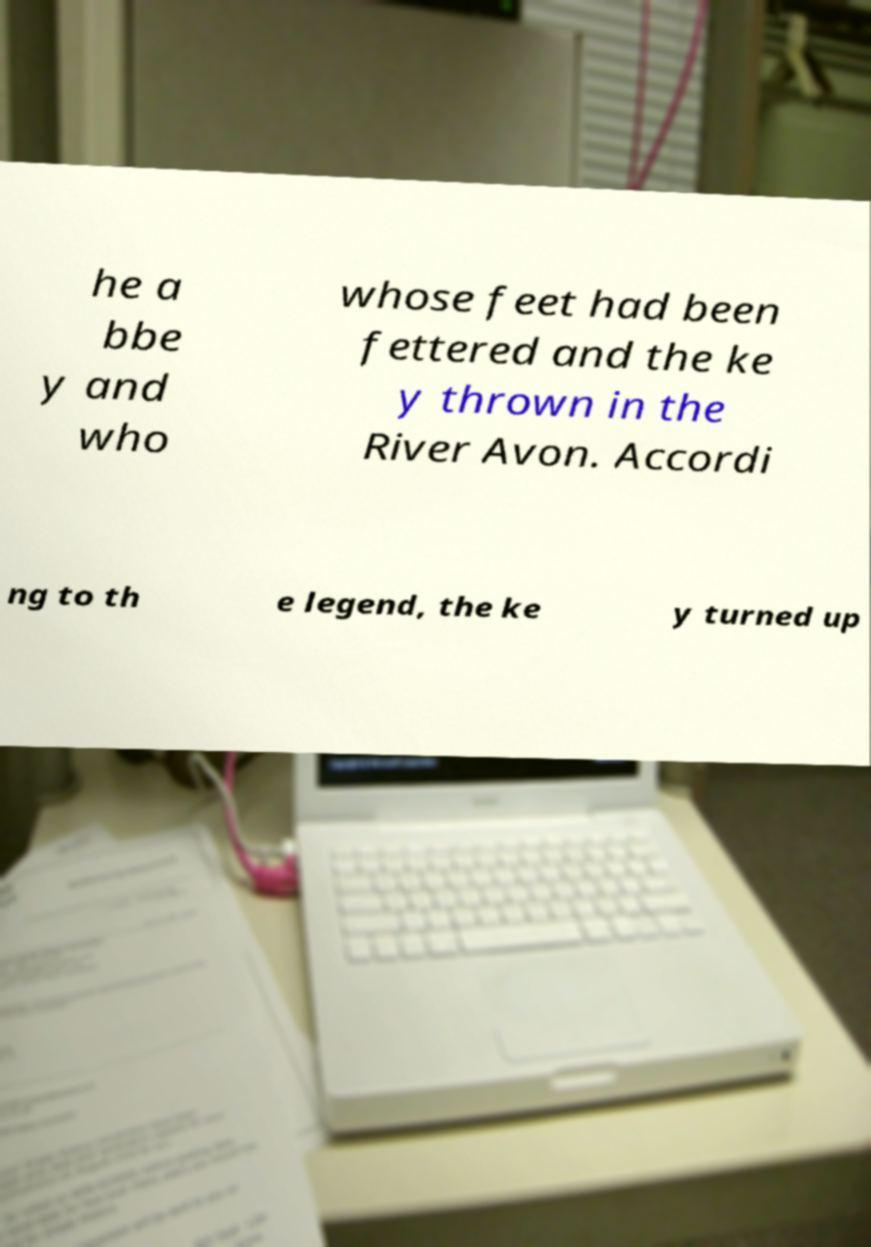Please identify and transcribe the text found in this image. he a bbe y and who whose feet had been fettered and the ke y thrown in the River Avon. Accordi ng to th e legend, the ke y turned up 